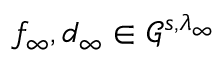<formula> <loc_0><loc_0><loc_500><loc_500>f _ { \infty } , d _ { \infty } \in \mathcal { G } ^ { s , \lambda _ { \infty } }</formula> 